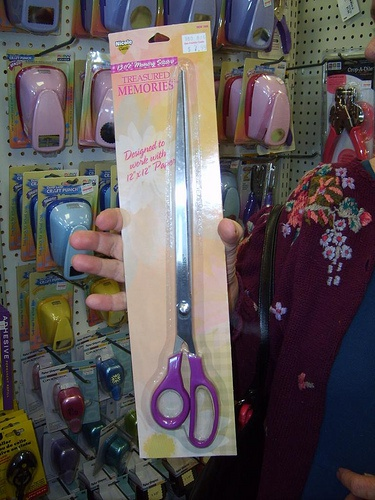Describe the objects in this image and their specific colors. I can see people in black, brown, gray, and maroon tones, scissors in black, darkgray, purple, gray, and white tones, and handbag in black, navy, darkblue, and gray tones in this image. 